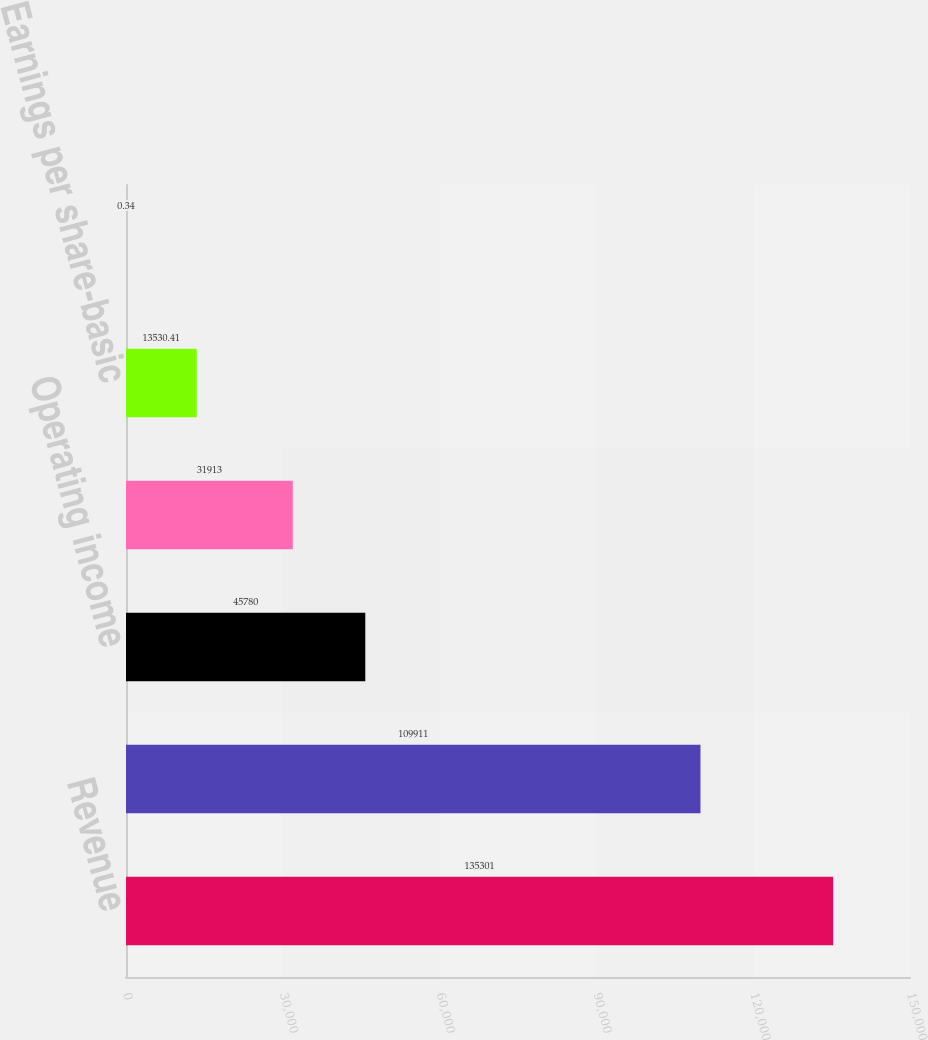<chart> <loc_0><loc_0><loc_500><loc_500><bar_chart><fcel>Revenue<fcel>Gross profit<fcel>Operating income<fcel>Net income<fcel>Earnings per share-basic<fcel>Earnings per share-diluted<nl><fcel>135301<fcel>109911<fcel>45780<fcel>31913<fcel>13530.4<fcel>0.34<nl></chart> 